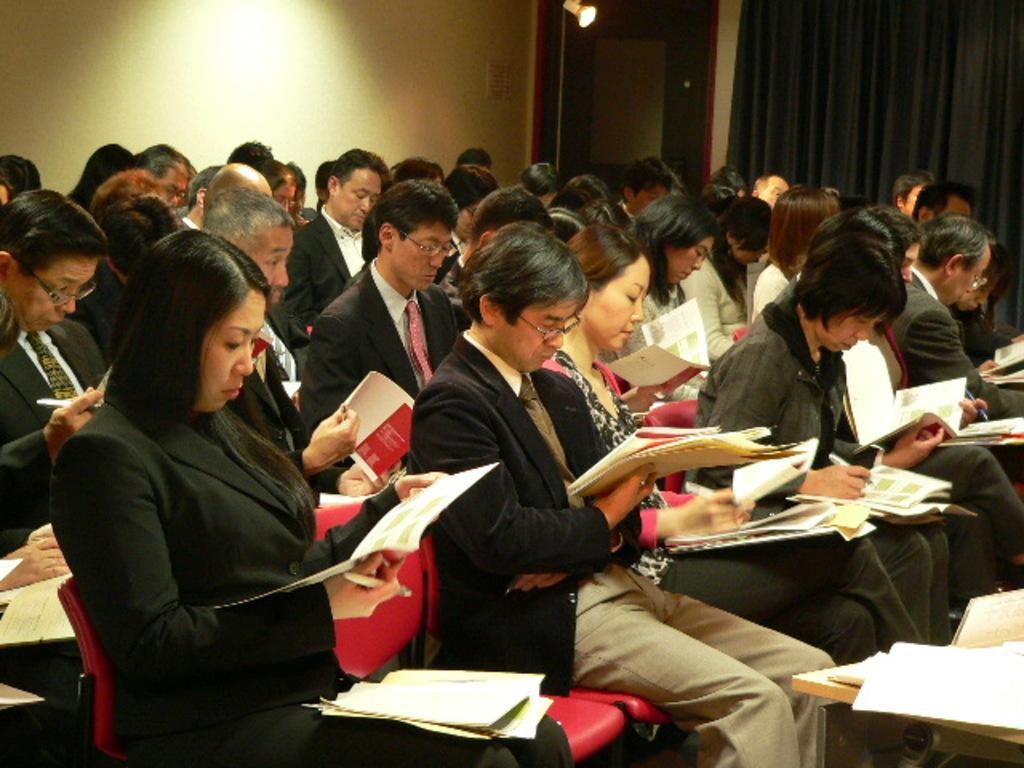How would you summarize this image in a sentence or two? A group of people are sitting on a chair and holding books and papers. Far there is a black curtain. On top there is a light. Most of the persons wore black suit. In-front of this person there is a table, on a table there are papers. 